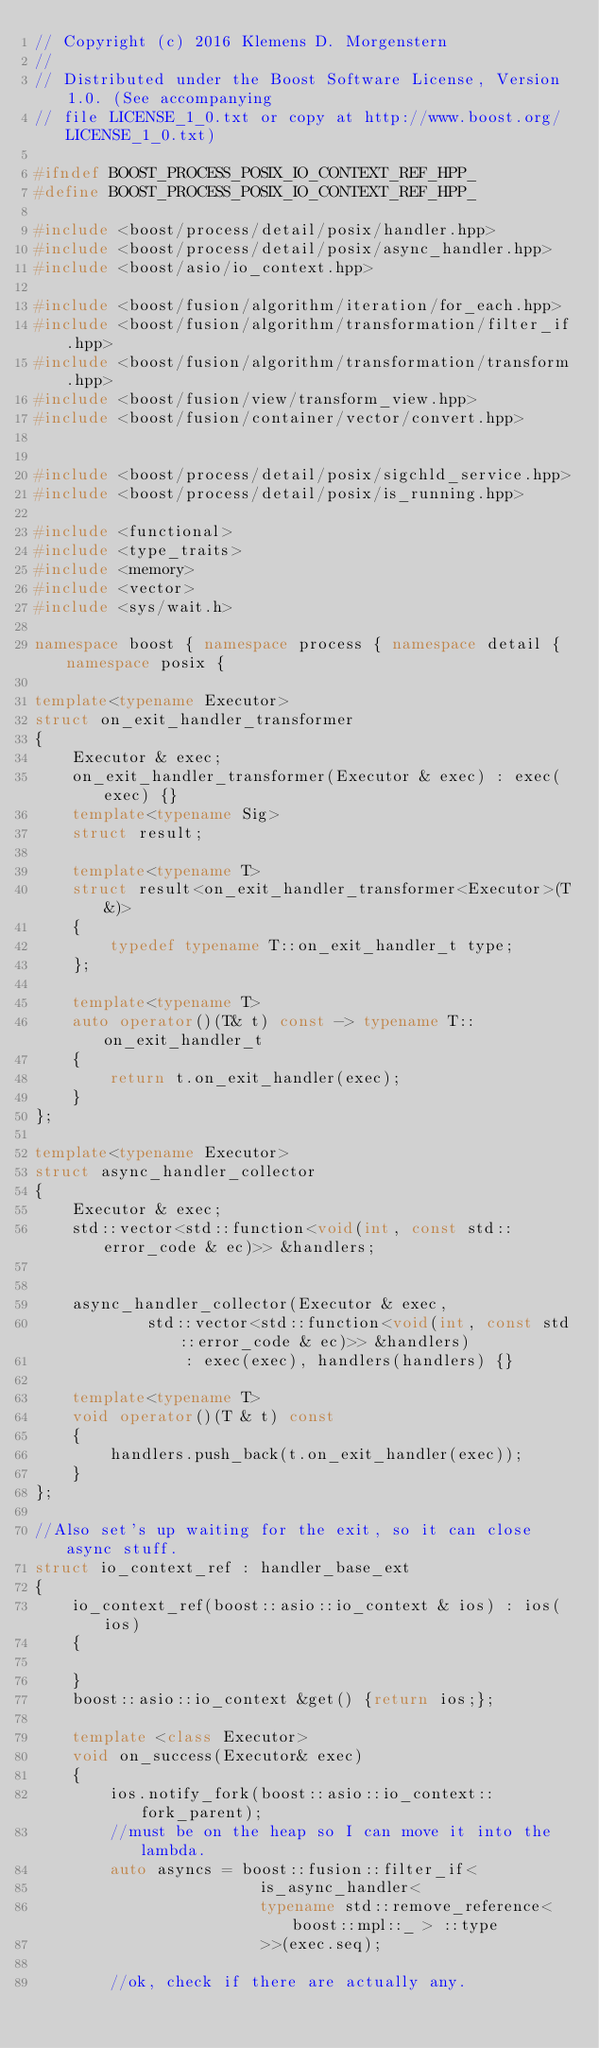Convert code to text. <code><loc_0><loc_0><loc_500><loc_500><_C++_>// Copyright (c) 2016 Klemens D. Morgenstern
//
// Distributed under the Boost Software License, Version 1.0. (See accompanying
// file LICENSE_1_0.txt or copy at http://www.boost.org/LICENSE_1_0.txt)

#ifndef BOOST_PROCESS_POSIX_IO_CONTEXT_REF_HPP_
#define BOOST_PROCESS_POSIX_IO_CONTEXT_REF_HPP_

#include <boost/process/detail/posix/handler.hpp>
#include <boost/process/detail/posix/async_handler.hpp>
#include <boost/asio/io_context.hpp>

#include <boost/fusion/algorithm/iteration/for_each.hpp>
#include <boost/fusion/algorithm/transformation/filter_if.hpp>
#include <boost/fusion/algorithm/transformation/transform.hpp>
#include <boost/fusion/view/transform_view.hpp>
#include <boost/fusion/container/vector/convert.hpp>


#include <boost/process/detail/posix/sigchld_service.hpp>
#include <boost/process/detail/posix/is_running.hpp>

#include <functional>
#include <type_traits>
#include <memory>
#include <vector>
#include <sys/wait.h>

namespace boost { namespace process { namespace detail { namespace posix {

template<typename Executor>
struct on_exit_handler_transformer
{
    Executor & exec;
    on_exit_handler_transformer(Executor & exec) : exec(exec) {}
    template<typename Sig>
    struct result;

    template<typename T>
    struct result<on_exit_handler_transformer<Executor>(T&)>
    {
        typedef typename T::on_exit_handler_t type;
    };

    template<typename T>
    auto operator()(T& t) const -> typename T::on_exit_handler_t
    {
        return t.on_exit_handler(exec);
    }
};

template<typename Executor>
struct async_handler_collector
{
    Executor & exec;
    std::vector<std::function<void(int, const std::error_code & ec)>> &handlers;


    async_handler_collector(Executor & exec,
            std::vector<std::function<void(int, const std::error_code & ec)>> &handlers)
                : exec(exec), handlers(handlers) {}

    template<typename T>
    void operator()(T & t) const
    {
        handlers.push_back(t.on_exit_handler(exec));
    }
};

//Also set's up waiting for the exit, so it can close async stuff.
struct io_context_ref : handler_base_ext
{
    io_context_ref(boost::asio::io_context & ios) : ios(ios)
    {

    }
    boost::asio::io_context &get() {return ios;};
    
    template <class Executor>
    void on_success(Executor& exec)
    {
        ios.notify_fork(boost::asio::io_context::fork_parent);
        //must be on the heap so I can move it into the lambda.
        auto asyncs = boost::fusion::filter_if<
                        is_async_handler<
                        typename std::remove_reference< boost::mpl::_ > ::type
                        >>(exec.seq);

        //ok, check if there are actually any.</code> 